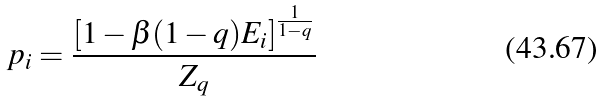Convert formula to latex. <formula><loc_0><loc_0><loc_500><loc_500>p _ { i } = \frac { [ 1 - \beta ( 1 - q ) E _ { i } ] ^ { \frac { 1 } { 1 - q } } } { Z _ { q } }</formula> 